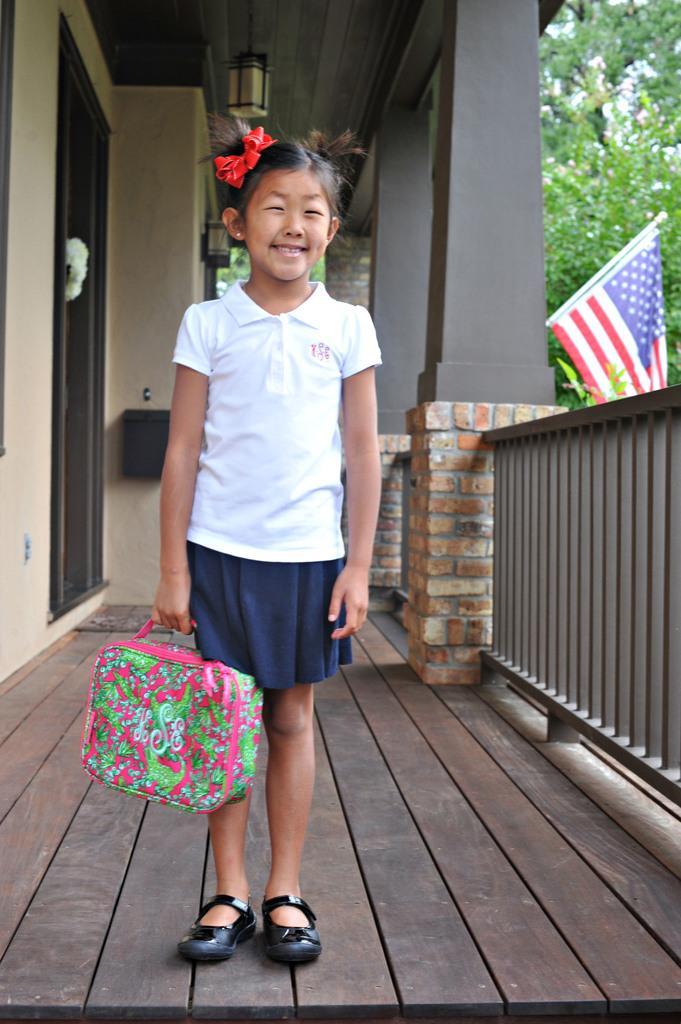In one or two sentences, can you explain what this image depicts? In this image we can see a child holding a bag. On the backside we can see some pillars, ceiling light, door, flag, trees and a fence. 